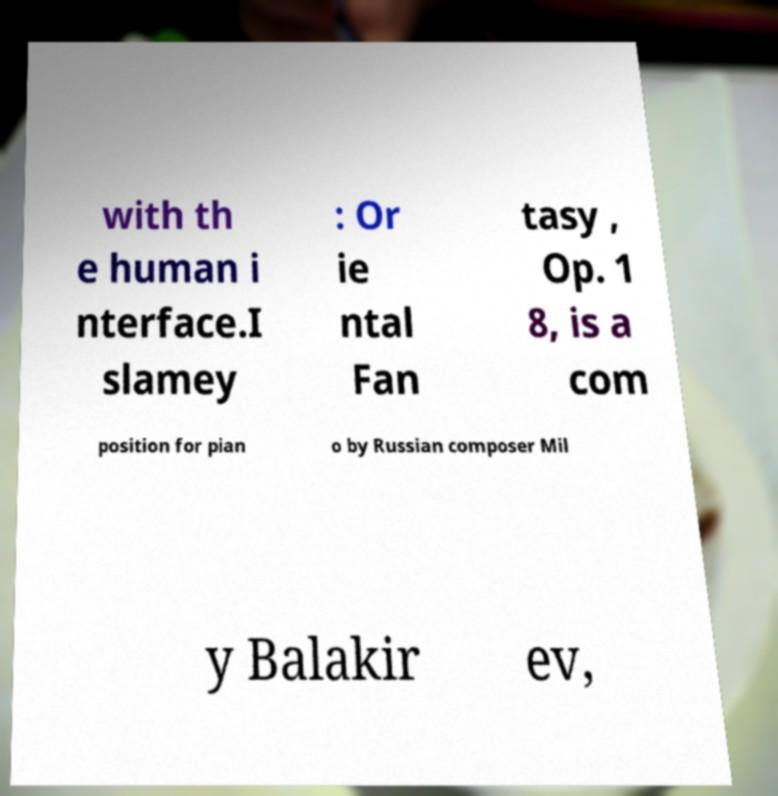I need the written content from this picture converted into text. Can you do that? with th e human i nterface.I slamey : Or ie ntal Fan tasy , Op. 1 8, is a com position for pian o by Russian composer Mil y Balakir ev, 